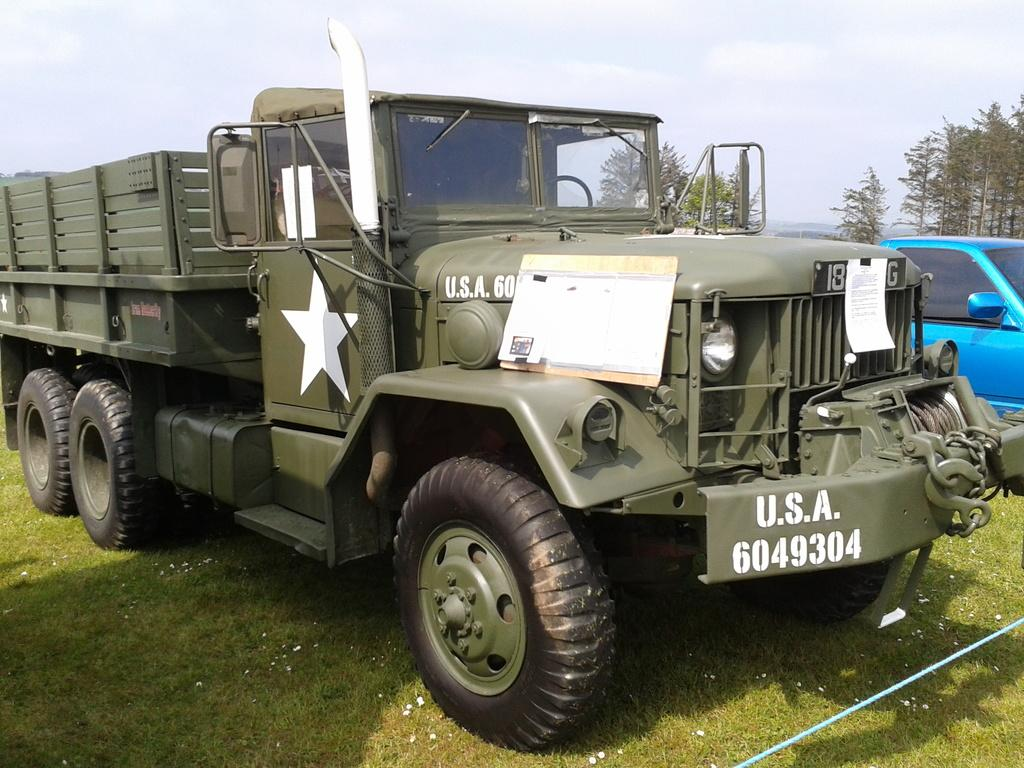What types of objects are on the ground in the image? There are vehicles on the ground in the image. What is the rope used for in the image? The purpose of the rope is not clear from the image. What type of vegetation is present in the image? There is grass in the image. What can be seen in the background of the image? There are trees and the sky visible in the background of the image. How many houses are visible in the image? There are no houses present in the image. What type of show is being performed in the image? There is no show being performed in the image. 